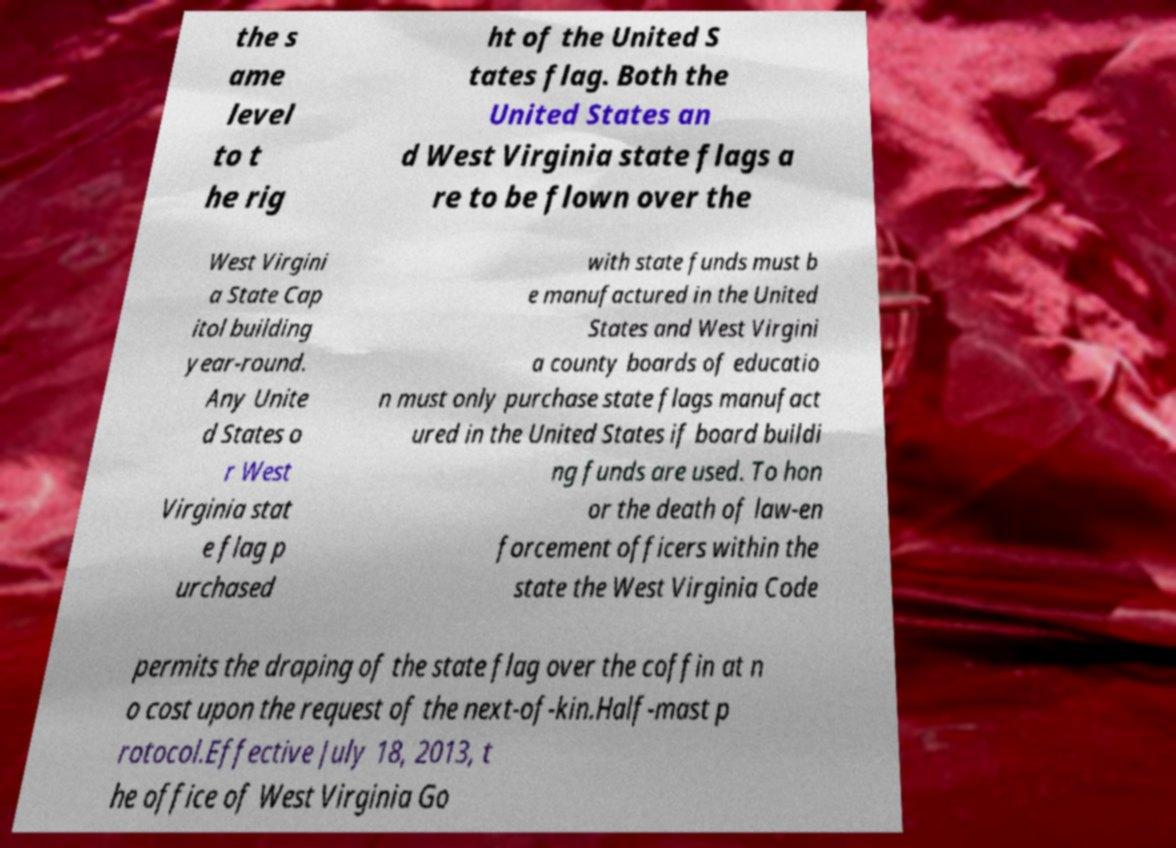Can you read and provide the text displayed in the image?This photo seems to have some interesting text. Can you extract and type it out for me? the s ame level to t he rig ht of the United S tates flag. Both the United States an d West Virginia state flags a re to be flown over the West Virgini a State Cap itol building year-round. Any Unite d States o r West Virginia stat e flag p urchased with state funds must b e manufactured in the United States and West Virgini a county boards of educatio n must only purchase state flags manufact ured in the United States if board buildi ng funds are used. To hon or the death of law-en forcement officers within the state the West Virginia Code permits the draping of the state flag over the coffin at n o cost upon the request of the next-of-kin.Half-mast p rotocol.Effective July 18, 2013, t he office of West Virginia Go 